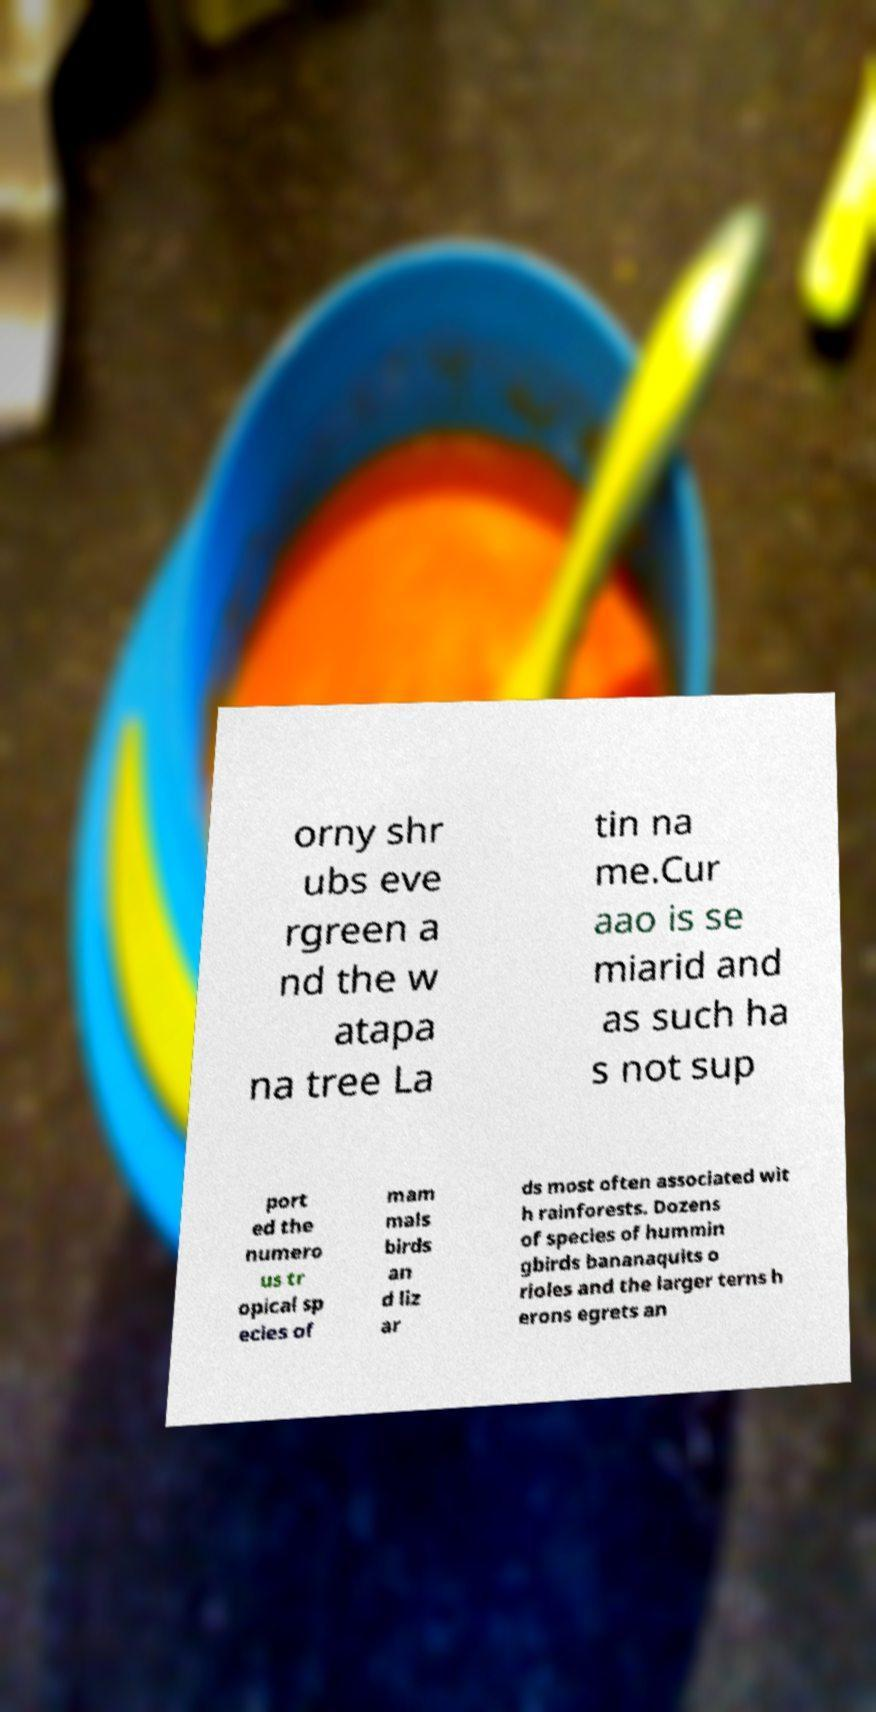For documentation purposes, I need the text within this image transcribed. Could you provide that? orny shr ubs eve rgreen a nd the w atapa na tree La tin na me.Cur aao is se miarid and as such ha s not sup port ed the numero us tr opical sp ecies of mam mals birds an d liz ar ds most often associated wit h rainforests. Dozens of species of hummin gbirds bananaquits o rioles and the larger terns h erons egrets an 